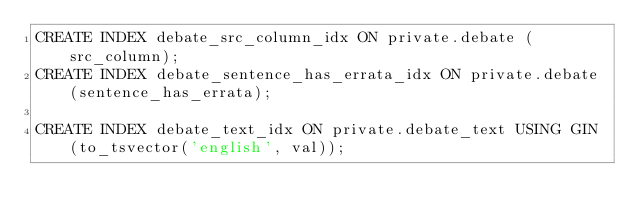<code> <loc_0><loc_0><loc_500><loc_500><_SQL_>CREATE INDEX debate_src_column_idx ON private.debate (src_column);
CREATE INDEX debate_sentence_has_errata_idx ON private.debate (sentence_has_errata);

CREATE INDEX debate_text_idx ON private.debate_text USING GIN (to_tsvector('english', val));
</code> 